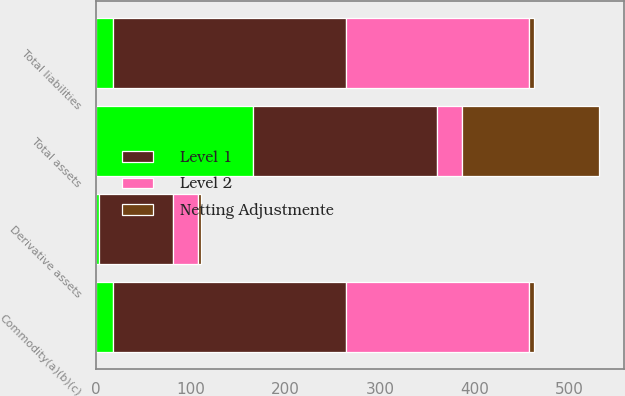Convert chart. <chart><loc_0><loc_0><loc_500><loc_500><stacked_bar_chart><ecel><fcel>Derivative assets<fcel>Total assets<fcel>Commodity(a)(b)(c)<fcel>Total liabilities<nl><fcel>nan<fcel>3<fcel>166<fcel>18<fcel>18<nl><fcel>Level 1<fcel>78<fcel>194<fcel>246<fcel>246<nl><fcel>Level 2<fcel>27<fcel>27<fcel>194<fcel>194<nl><fcel>Netting Adjustmente<fcel>3<fcel>144<fcel>5<fcel>5<nl></chart> 